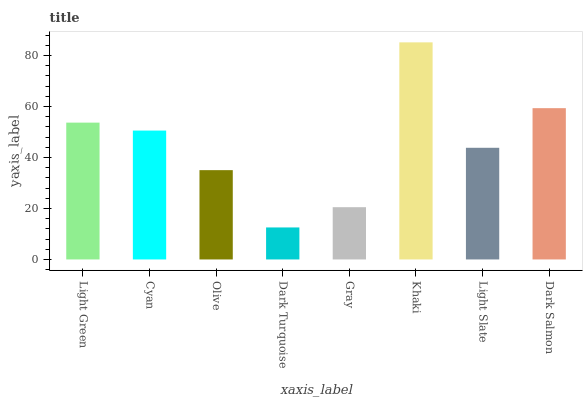Is Cyan the minimum?
Answer yes or no. No. Is Cyan the maximum?
Answer yes or no. No. Is Light Green greater than Cyan?
Answer yes or no. Yes. Is Cyan less than Light Green?
Answer yes or no. Yes. Is Cyan greater than Light Green?
Answer yes or no. No. Is Light Green less than Cyan?
Answer yes or no. No. Is Cyan the high median?
Answer yes or no. Yes. Is Light Slate the low median?
Answer yes or no. Yes. Is Light Green the high median?
Answer yes or no. No. Is Dark Salmon the low median?
Answer yes or no. No. 